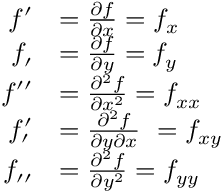<formula> <loc_0><loc_0><loc_500><loc_500>{ \begin{array} { r l } { f ^ { \prime } } & { = { \frac { \partial f } { \partial x } } = f _ { x } } \\ { f _ { \prime } } & { = { \frac { \partial f } { \partial y } } = f _ { y } } \\ { f ^ { \prime \prime } } & { = { \frac { \partial ^ { 2 } f } { \partial x ^ { 2 } } } = f _ { x x } } \\ { f _ { \prime } ^ { \prime } } & { = { \frac { \partial ^ { 2 } f } { \partial y \partial x } } \ = f _ { x y } } \\ { f _ { \prime \prime } } & { = { \frac { \partial ^ { 2 } f } { \partial y ^ { 2 } } } = f _ { y y } } \end{array} }</formula> 